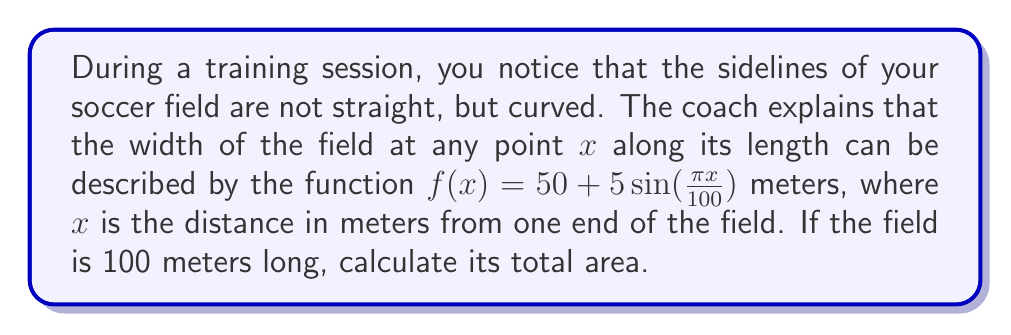Solve this math problem. To find the area of the soccer field with curved boundaries, we need to use integration. Here's how we can approach this problem:

1) The width of the field is given by the function $f(x) = 50 + 5\sin(\frac{\pi x}{100})$ meters.

2) The length of the field is 100 meters, so we need to integrate from $x = 0$ to $x = 100$.

3) The area of the field can be found by integrating the width function over the length:

   $$A = \int_0^{100} f(x) dx = \int_0^{100} (50 + 5\sin(\frac{\pi x}{100})) dx$$

4) Let's break this into two integrals:

   $$A = \int_0^{100} 50 dx + \int_0^{100} 5\sin(\frac{\pi x}{100}) dx$$

5) The first integral is straightforward:

   $$\int_0^{100} 50 dx = 50x \bigg|_0^{100} = 5000$$

6) For the second integral, we can use u-substitution:
   Let $u = \frac{\pi x}{100}$, then $du = \frac{\pi}{100} dx$ or $dx = \frac{100}{\pi} du$

   When $x = 0$, $u = 0$
   When $x = 100$, $u = \pi$

   $$\int_0^{100} 5\sin(\frac{\pi x}{100}) dx = 5 \cdot \frac{100}{\pi} \int_0^{\pi} \sin(u) du$$

7) We know that $\int \sin(u) du = -\cos(u) + C$, so:

   $$5 \cdot \frac{100}{\pi} \int_0^{\pi} \sin(u) du = 5 \cdot \frac{100}{\pi} [-\cos(u)]_0^{\pi} = 5 \cdot \frac{100}{\pi} [-\cos(\pi) + \cos(0)] = 5 \cdot \frac{100}{\pi} [1 + 1] = \frac{1000}{\pi}$$

8) Adding the results from steps 5 and 7:

   $$A = 5000 + \frac{1000}{\pi}$$
Answer: The total area of the soccer field is $5000 + \frac{1000}{\pi}$ square meters, or approximately 5318.31 square meters. 